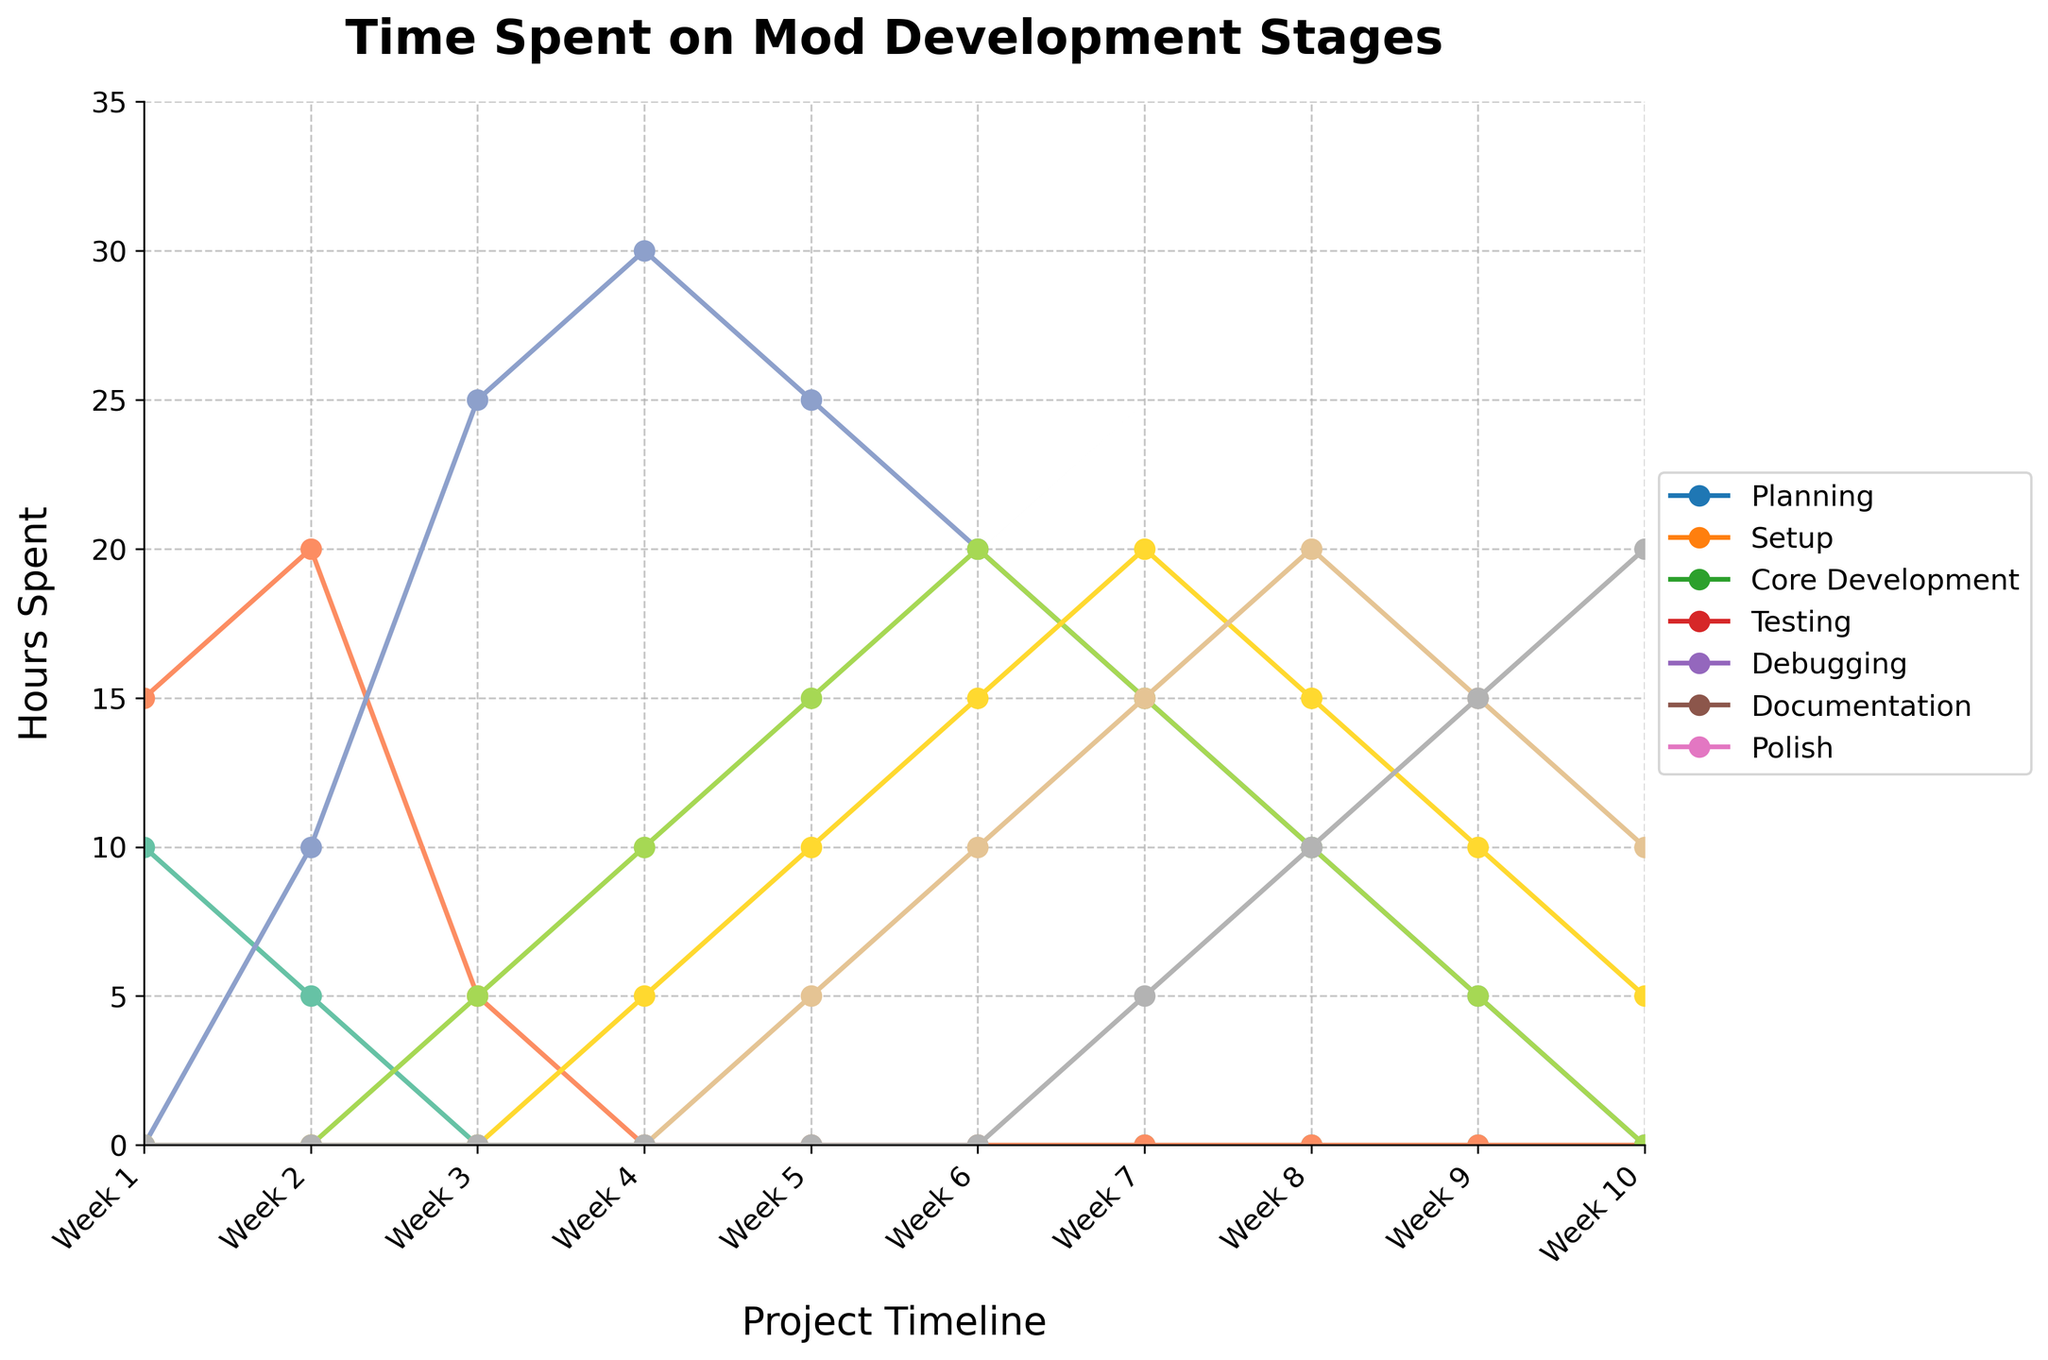Which stage had the highest number of hours spent in Week 2? To determine this, look at the values for each stage in Week 2. The hours spent are 5 (Planning), 20 (Setup), and 10 (Core Development). No hours are recorded for the other stages. The maximum value is 20 for Setup.
Answer: Setup During which week was the most time spent on Core Development? To find this, observe the values for Core Development across all weeks. The values are 0, 10, 25, 30, 25, 20, 15, 10, 5, 0. The highest value is 30 in Week 4.
Answer: Week 4 How many hours were spent on Testing in Weeks 5 and 6 combined? Sum the hours spent on Testing in Week 5 and Week 6. The values are 15 and 20 respectively, so the total is 15 + 20 = 35 hours.
Answer: 35 Which stage shows a gradual increase in hours spent from Week 6 to Week 10? Examine the stages to see which one shows an increasing trend over this period. Documentation starts at 10 hours in Week 6 and increases to 20 hours by Week 10. This indicates a gradual increase.
Answer: Documentation In which week does Debugging first start to take a significant amount of time? Identify the first week where Debugging hours are notably greater than zero. It starts at Week 4 with 5 hours and increases gradually in subsequent weeks.
Answer: Week 4 Compare the total hours spent on Planning and Documentation over the entire project. Which stage has more hours? Sum the hours for Planning (Weeks 1 and 2) and Documentation (Weeks 5-10). Planning: 10 + 5 = 15 hours. Documentation: 5 + 10 + 15 + 20 = 60 hours. Documentation has more hours.
Answer: Documentation What is the average number of hours spent on Polish during the last three weeks? Calculate the average by summing the hours for Polish in Weeks 8, 9, and 10 and dividing by 3. The values are 10, 15, and 20. The sum is 10 + 15 + 20 = 45. The average is 45/3 = 15 hours.
Answer: 15 Which stage saw the most dramatic decrease in hours between any two consecutive weeks? To find this, look for the largest drop in hours between consecutive weeks for any stage. Core Development drops from 30 hours in Week 4 to 25 hours in Week 5, which is a drop of 5 hours.
Answer: Core Development 